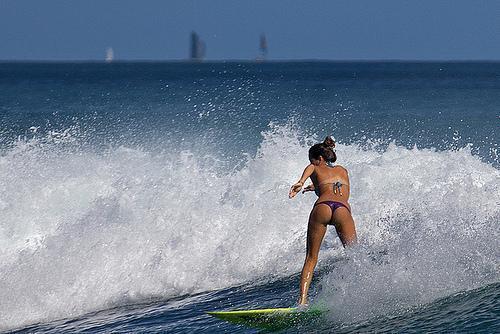How many people are in the photo?
Give a very brief answer. 1. 